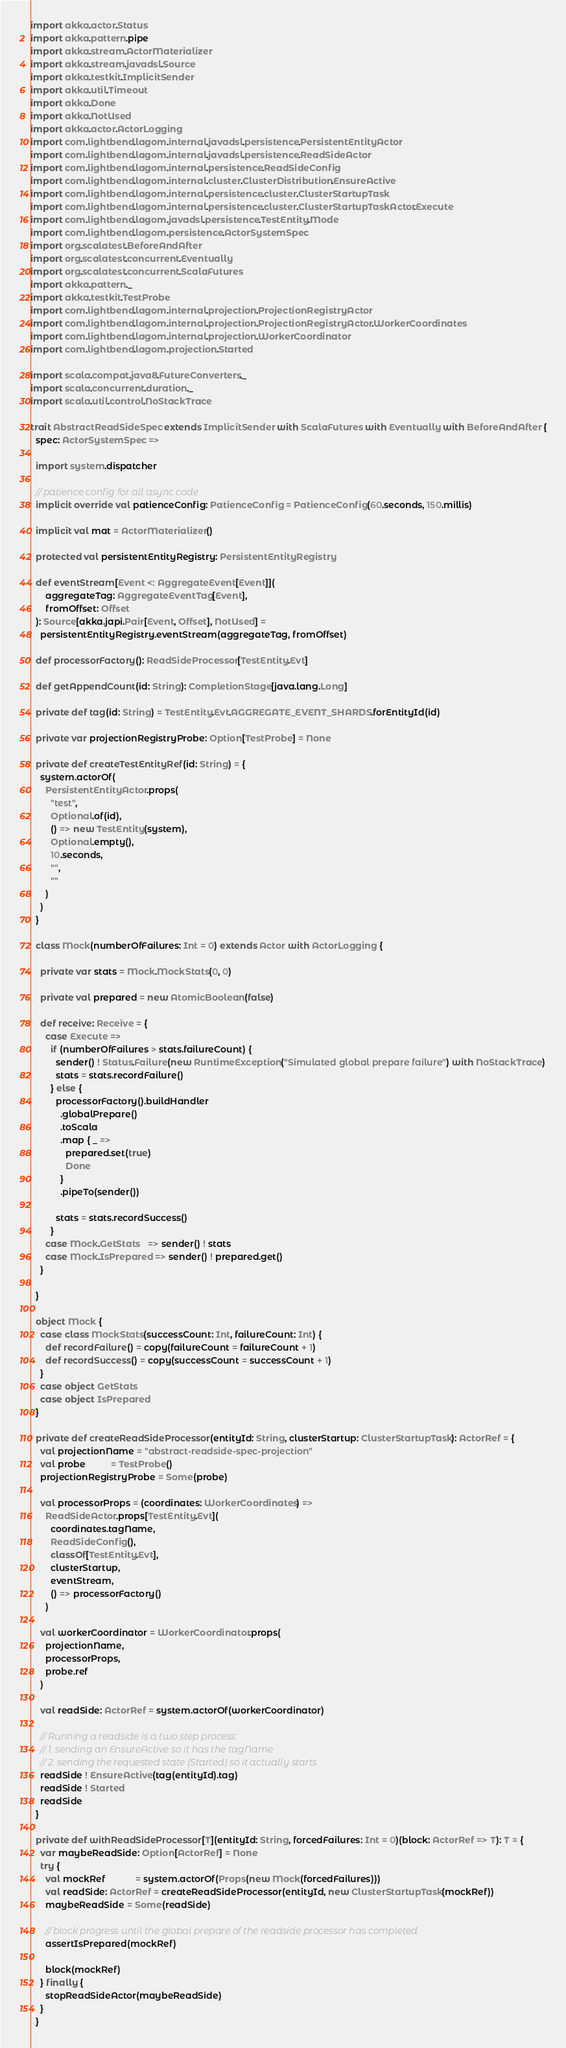Convert code to text. <code><loc_0><loc_0><loc_500><loc_500><_Scala_>import akka.actor.Status
import akka.pattern.pipe
import akka.stream.ActorMaterializer
import akka.stream.javadsl.Source
import akka.testkit.ImplicitSender
import akka.util.Timeout
import akka.Done
import akka.NotUsed
import akka.actor.ActorLogging
import com.lightbend.lagom.internal.javadsl.persistence.PersistentEntityActor
import com.lightbend.lagom.internal.javadsl.persistence.ReadSideActor
import com.lightbend.lagom.internal.persistence.ReadSideConfig
import com.lightbend.lagom.internal.cluster.ClusterDistribution.EnsureActive
import com.lightbend.lagom.internal.persistence.cluster.ClusterStartupTask
import com.lightbend.lagom.internal.persistence.cluster.ClusterStartupTaskActor.Execute
import com.lightbend.lagom.javadsl.persistence.TestEntity.Mode
import com.lightbend.lagom.persistence.ActorSystemSpec
import org.scalatest.BeforeAndAfter
import org.scalatest.concurrent.Eventually
import org.scalatest.concurrent.ScalaFutures
import akka.pattern._
import akka.testkit.TestProbe
import com.lightbend.lagom.internal.projection.ProjectionRegistryActor
import com.lightbend.lagom.internal.projection.ProjectionRegistryActor.WorkerCoordinates
import com.lightbend.lagom.internal.projection.WorkerCoordinator
import com.lightbend.lagom.projection.Started

import scala.compat.java8.FutureConverters._
import scala.concurrent.duration._
import scala.util.control.NoStackTrace

trait AbstractReadSideSpec extends ImplicitSender with ScalaFutures with Eventually with BeforeAndAfter {
  spec: ActorSystemSpec =>

  import system.dispatcher

  // patience config for all async code
  implicit override val patienceConfig: PatienceConfig = PatienceConfig(60.seconds, 150.millis)

  implicit val mat = ActorMaterializer()

  protected val persistentEntityRegistry: PersistentEntityRegistry

  def eventStream[Event <: AggregateEvent[Event]](
      aggregateTag: AggregateEventTag[Event],
      fromOffset: Offset
  ): Source[akka.japi.Pair[Event, Offset], NotUsed] =
    persistentEntityRegistry.eventStream(aggregateTag, fromOffset)

  def processorFactory(): ReadSideProcessor[TestEntity.Evt]

  def getAppendCount(id: String): CompletionStage[java.lang.Long]

  private def tag(id: String) = TestEntity.Evt.AGGREGATE_EVENT_SHARDS.forEntityId(id)

  private var projectionRegistryProbe: Option[TestProbe] = None

  private def createTestEntityRef(id: String) = {
    system.actorOf(
      PersistentEntityActor.props(
        "test",
        Optional.of(id),
        () => new TestEntity(system),
        Optional.empty(),
        10.seconds,
        "",
        ""
      )
    )
  }

  class Mock(numberOfFailures: Int = 0) extends Actor with ActorLogging {

    private var stats = Mock.MockStats(0, 0)

    private val prepared = new AtomicBoolean(false)

    def receive: Receive = {
      case Execute =>
        if (numberOfFailures > stats.failureCount) {
          sender() ! Status.Failure(new RuntimeException("Simulated global prepare failure") with NoStackTrace)
          stats = stats.recordFailure()
        } else {
          processorFactory().buildHandler
            .globalPrepare()
            .toScala
            .map { _ =>
              prepared.set(true)
              Done
            }
            .pipeTo(sender())

          stats = stats.recordSuccess()
        }
      case Mock.GetStats   => sender() ! stats
      case Mock.IsPrepared => sender() ! prepared.get()
    }

  }

  object Mock {
    case class MockStats(successCount: Int, failureCount: Int) {
      def recordFailure() = copy(failureCount = failureCount + 1)
      def recordSuccess() = copy(successCount = successCount + 1)
    }
    case object GetStats
    case object IsPrepared
  }

  private def createReadSideProcessor(entityId: String, clusterStartup: ClusterStartupTask): ActorRef = {
    val projectionName = "abstract-readside-spec-projection"
    val probe          = TestProbe()
    projectionRegistryProbe = Some(probe)

    val processorProps = (coordinates: WorkerCoordinates) =>
      ReadSideActor.props[TestEntity.Evt](
        coordinates.tagName,
        ReadSideConfig(),
        classOf[TestEntity.Evt],
        clusterStartup,
        eventStream,
        () => processorFactory()
      )

    val workerCoordinator = WorkerCoordinator.props(
      projectionName,
      processorProps,
      probe.ref
    )

    val readSide: ActorRef = system.actorOf(workerCoordinator)

    // Running a readside is a two step process:
    // 1. sending an EnsureActive so it has the tagName
    // 2. sending the requested state (Started) so it actually starts
    readSide ! EnsureActive(tag(entityId).tag)
    readSide ! Started
    readSide
  }

  private def withReadSideProcessor[T](entityId: String, forcedFailures: Int = 0)(block: ActorRef => T): T = {
    var maybeReadSide: Option[ActorRef] = None
    try {
      val mockRef            = system.actorOf(Props(new Mock(forcedFailures)))
      val readSide: ActorRef = createReadSideProcessor(entityId, new ClusterStartupTask(mockRef))
      maybeReadSide = Some(readSide)

      // block progress until the global prepare of the readside processor has completed
      assertIsPrepared(mockRef)

      block(mockRef)
    } finally {
      stopReadSideActor(maybeReadSide)
    }
  }
</code> 